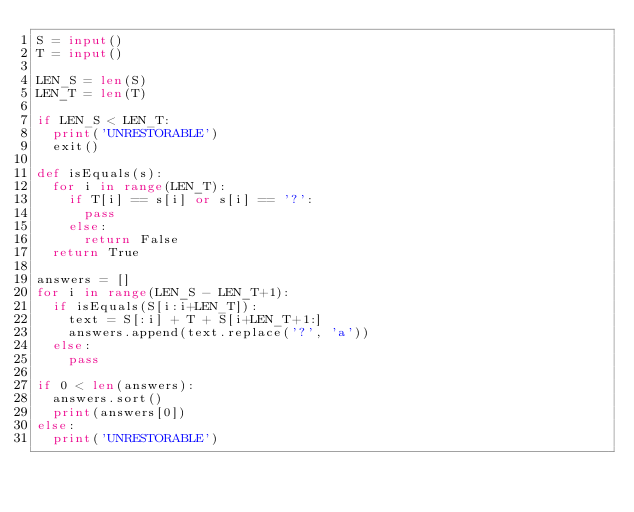Convert code to text. <code><loc_0><loc_0><loc_500><loc_500><_Python_>S = input()
T = input()

LEN_S = len(S)
LEN_T = len(T)

if LEN_S < LEN_T:
  print('UNRESTORABLE')
  exit()

def isEquals(s):
  for i in range(LEN_T):
    if T[i] == s[i] or s[i] == '?':
      pass
    else:
      return False
  return True

answers = []
for i in range(LEN_S - LEN_T+1):
  if isEquals(S[i:i+LEN_T]):
    text = S[:i] + T + S[i+LEN_T+1:]
    answers.append(text.replace('?', 'a'))
  else:
    pass

if 0 < len(answers):
  answers.sort()
  print(answers[0])
else:
  print('UNRESTORABLE')</code> 